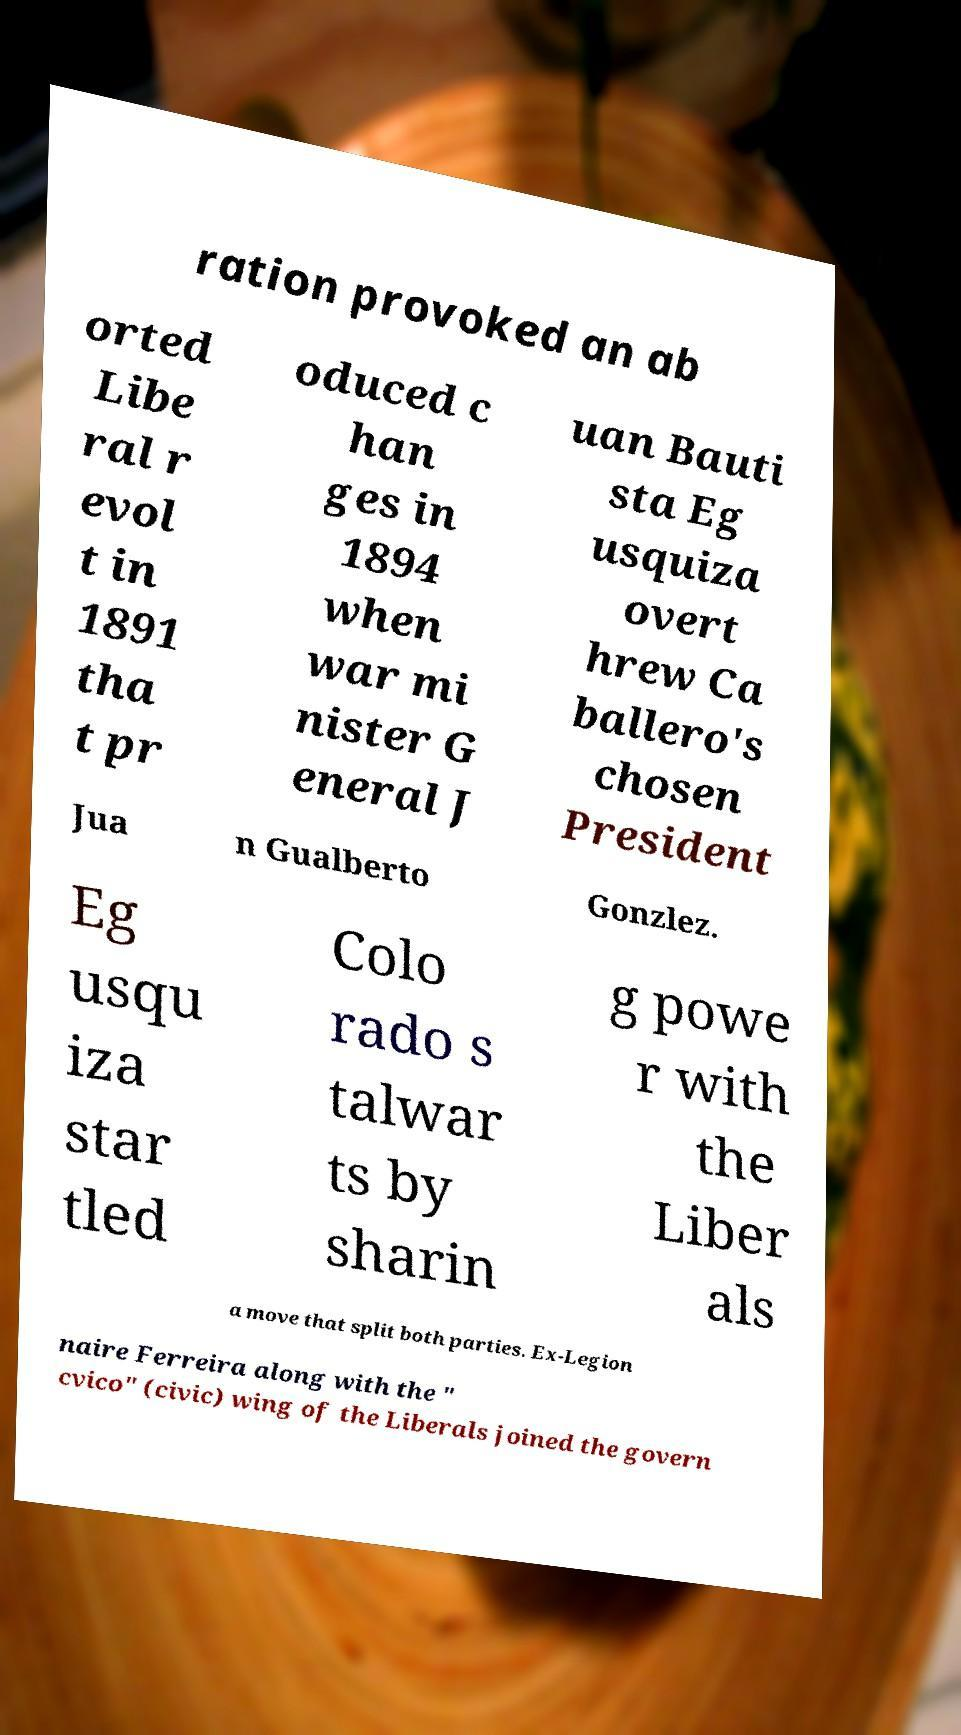Please identify and transcribe the text found in this image. ration provoked an ab orted Libe ral r evol t in 1891 tha t pr oduced c han ges in 1894 when war mi nister G eneral J uan Bauti sta Eg usquiza overt hrew Ca ballero's chosen President Jua n Gualberto Gonzlez. Eg usqu iza star tled Colo rado s talwar ts by sharin g powe r with the Liber als a move that split both parties. Ex-Legion naire Ferreira along with the " cvico" (civic) wing of the Liberals joined the govern 